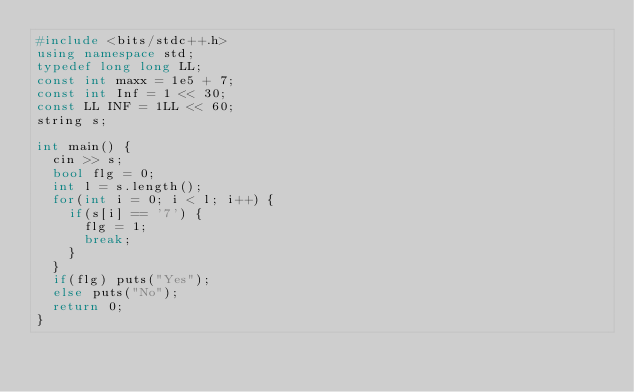Convert code to text. <code><loc_0><loc_0><loc_500><loc_500><_C++_>#include <bits/stdc++.h>
using namespace std;
typedef long long LL;
const int maxx = 1e5 + 7;
const int Inf = 1 << 30;
const LL INF = 1LL << 60;
string s;

int main() {
	cin >> s;
	bool flg = 0;
	int l = s.length();
	for(int i = 0; i < l; i++) {
		if(s[i] == '7') {
			flg = 1;
			break;
		}
	}
	if(flg) puts("Yes");
	else puts("No");
	return 0;
}</code> 